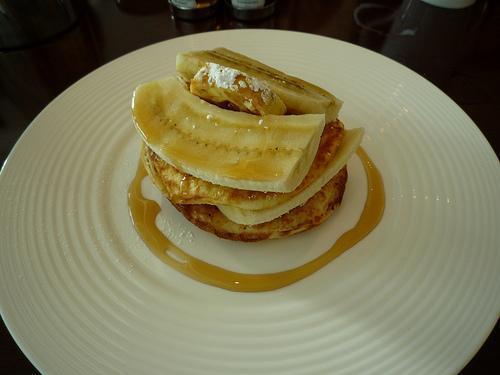How many pancakes are there?
Give a very brief answer. 2. 